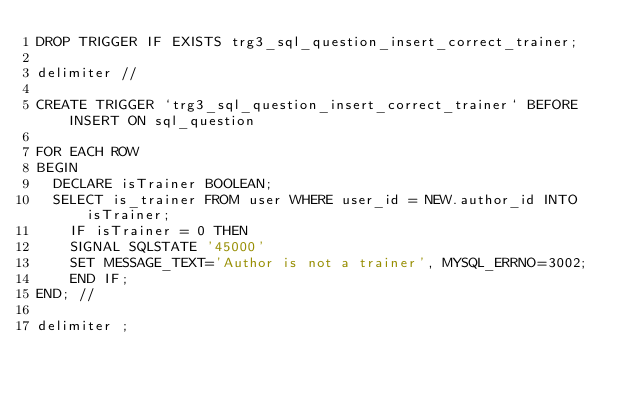<code> <loc_0><loc_0><loc_500><loc_500><_SQL_>DROP TRIGGER IF EXISTS trg3_sql_question_insert_correct_trainer;

delimiter //

CREATE TRIGGER `trg3_sql_question_insert_correct_trainer` BEFORE INSERT ON sql_question

FOR EACH ROW
BEGIN
	DECLARE isTrainer BOOLEAN;
	SELECT is_trainer FROM user WHERE user_id = NEW.author_id INTO isTrainer;
    IF isTrainer = 0 THEN
		SIGNAL SQLSTATE '45000'
		SET MESSAGE_TEXT='Author is not a trainer', MYSQL_ERRNO=3002;
    END IF;
END; //

delimiter ;
</code> 